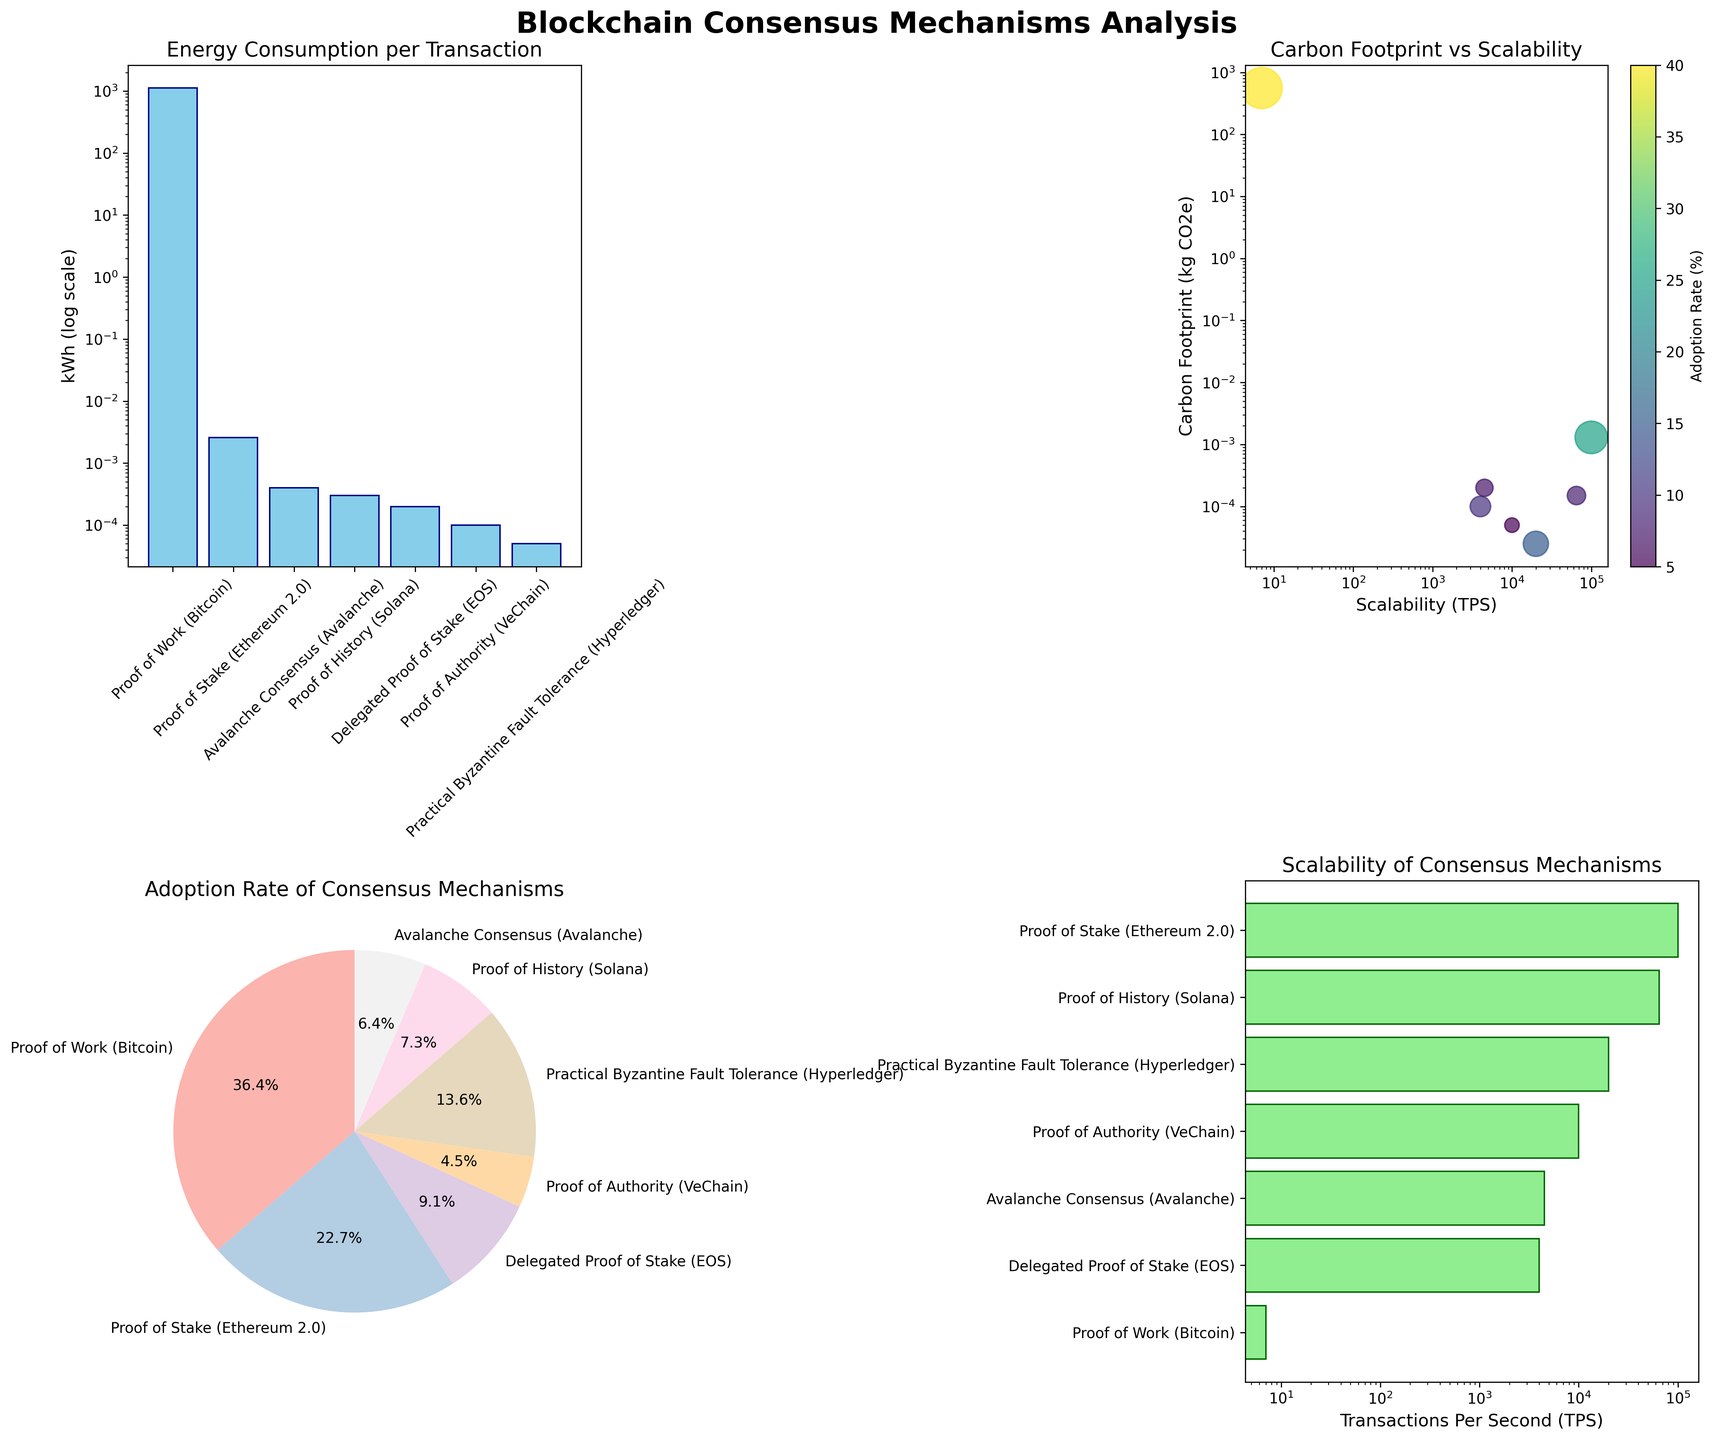What's the most energy-consuming blockchain consensus mechanism? The bar plot in the top-left corner is titled "Energy Consumption per Transaction." By observing the bars on a log scale, the longest bar corresponds to "Proof of Work (Bitcoin)."
Answer: Proof of Work (Bitcoin) What is the scalability (TPS) of the Proof of History (Solana) mechanism? The horizontal bar chart in the bottom-right corner titled "Scalability of Consensus Mechanisms" shows the TPS values. The bar labeled "Proof of History (Solana)" has a length corresponding to 65,000 TPS on the log scale.
Answer: 65,000 Which consensus mechanism has the smallest carbon footprint per transaction? The scatter plot in the top-right corner, titled "Carbon Footprint vs Scalability," shows different data points. The lowest point on the vertical axis, indicating the smallest carbon footprint, is associated with "Practical Byzantine Fault Tolerance (Hyperledger)."
Answer: Practical Byzantine Fault Tolerance (Hyperledger) How does the adoption rate of Proof of Stake (Ethereum 2.0) compare to that of Delegated Proof of Stake (EOS)? The pie chart in the bottom-left corner titled "Adoption Rate of Consensus Mechanisms" shows various slices representing adoption rates. Proof of Stake (Ethereum 2.0) has a 25% adoption rate, while Delegated Proof of Stake (EOS) has a 10% adoption rate.
Answer: Higher Which consensus mechanism combines high scalability and low carbon footprint? The scatter plot in the top-right corner allows us to compare scalability (x-axis) and carbon footprint (y-axis). The data point for "Proof of Stake (Ethereum 2.0)" is located at a high TPS (100,000) and a low carbon footprint (0.0013), making it the best combination of these factors.
Answer: Proof of Stake (Ethereum 2.0) What's the difference in energy consumption between Proof of Work (Bitcoin) and Proof of Authority (VeChain)? The bar plot in the top-left corner shows energy consumption levels in kWh per transaction. Proof of Work (Bitcoin) has an energy consumption of 1122 kWh, while Proof of Authority (VeChain) has 0.0001 kWh. The difference is 1122 - 0.0001.
Answer: 1121.9999 kWh What percentage of the total adoption rate is held by Proof of History (Solana)? The pie chart in the bottom-left corner shows the adoption percentages. The slice for "Proof of History (Solana)" is labeled with 8%.
Answer: 8% Which consensus mechanism has the highest adoption rate and what is its value? The pie chart in the bottom-left corner shows different slices representing adoption rates. The largest slice belongs to "Proof of Work (Bitcoin)" with a 40% adoption rate.
Answer: Proof of Work (Bitcoin) with 40% How many consensus mechanisms have energy consumption levels below 1 kWh per transaction? The bar plot in the top-left corner shows energy consumption levels. All mechanisms except "Proof of Work (Bitcoin)" have bars much lower than 1 kWh when viewed on the log scale, giving a visual indication.
Answer: 6 mechanisms 